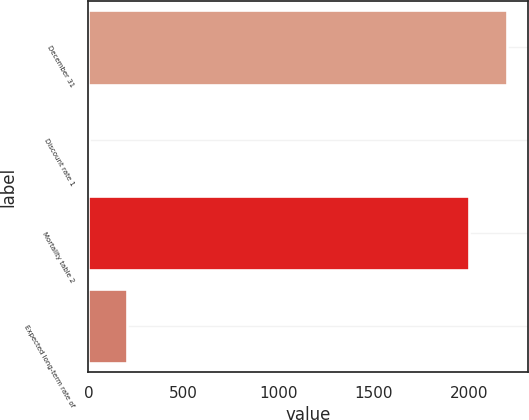Convert chart to OTSL. <chart><loc_0><loc_0><loc_500><loc_500><bar_chart><fcel>December 31<fcel>Discount rate 1<fcel>Mortality table 2<fcel>Expected long-term rate of<nl><fcel>2200.79<fcel>4.1<fcel>2000<fcel>204.89<nl></chart> 